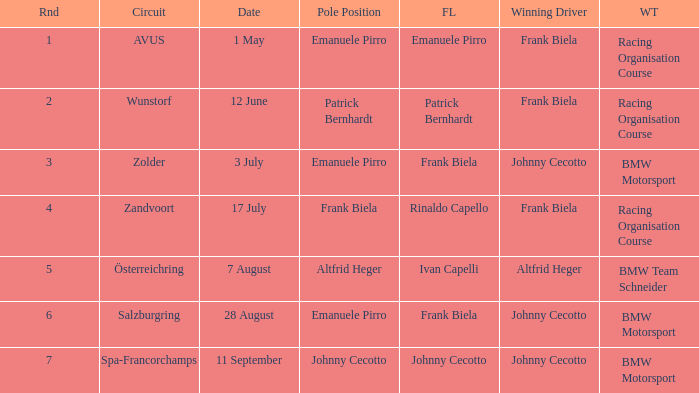Who was the winning team on the circuit Zolder? BMW Motorsport. 